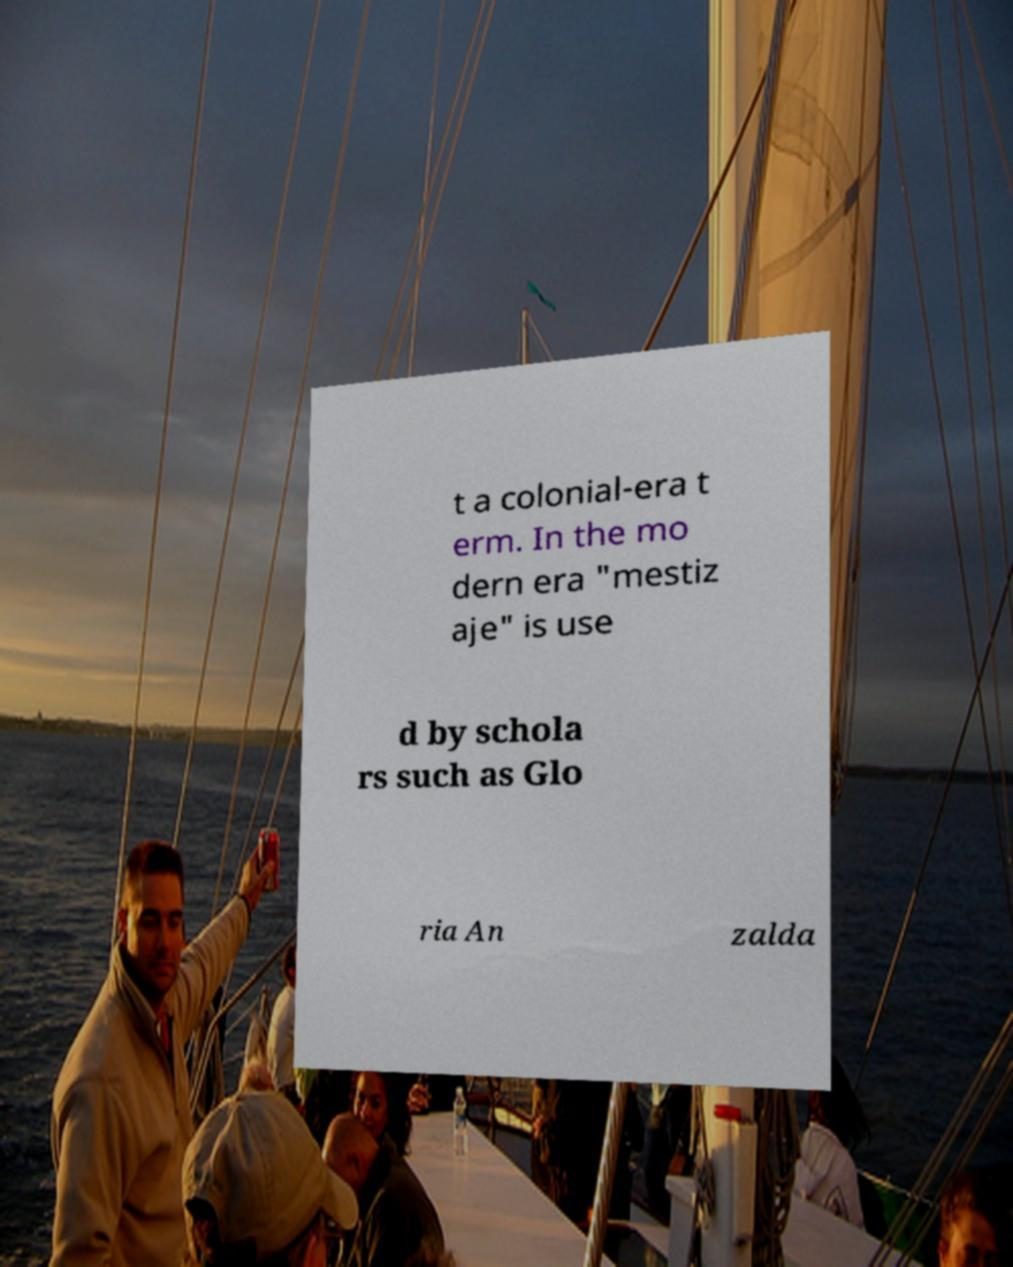Could you assist in decoding the text presented in this image and type it out clearly? t a colonial-era t erm. In the mo dern era "mestiz aje" is use d by schola rs such as Glo ria An zalda 